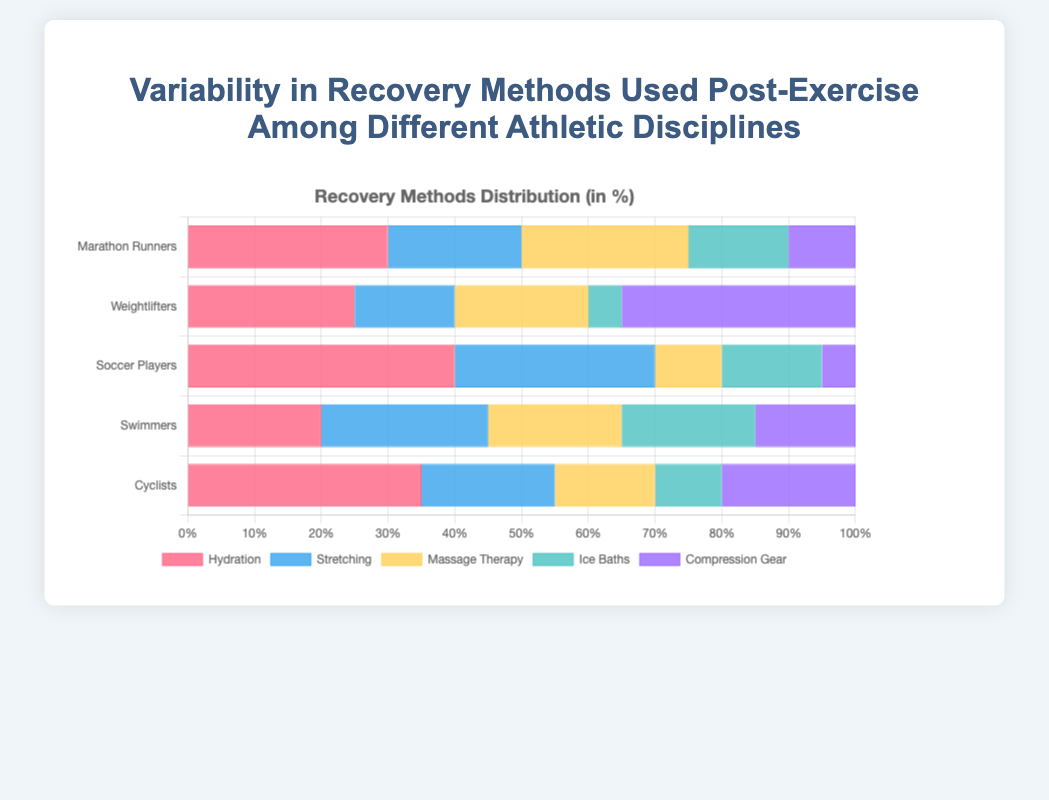Which athletic discipline uses "Hydration" the most? The bar representing "Hydration" for each athletic discipline needs to be checked. Soccer Players have the longest bar for "Hydration".
Answer: Soccer Players What is the total percentage use of "Massage Therapy" by Marathon Runners and Weightlifters? Marathon Runners use "Massage Therapy" 25% and Weightlifters use it 20%. Adding them gives 25 + 20 = 45.
Answer: 45% Which recovery method is least used by Weightlifters? The shortest bar for Weightlifters should be identified. "Ice Baths" have the shortest bar.
Answer: Ice Baths Compare the total use of "Compression Gear" between Weightlifters and Cyclists. Which group uses it more? Weightlifters' "Compression Gear" usage is 35%, and Cyclists' is 20%. 35% is greater than 20%.
Answer: Weightlifters How much more do Soccer Players use "Stretching" compared to Swimmers? Soccer Players use "Stretching" 30%, and Swimmers use it 25%. The difference is 30 - 25 = 5.
Answer: 5% Which recovery method shows the least variability in its usage across all athletic disciplines? Examine the range of usage (difference between maximum and minimum) for each recovery method. "Ice Baths" show the least variability with percentages of 5, 10, 15, 15, and 20.
Answer: Ice Baths Determine the average use of "Ice Baths" across all athletic disciplines. The percentages for "Ice Baths" are 15, 5, 15, 20, and 10. Summing them gives 65. Dividing by 5 (number of disciplines) gives 65/5 = 13.
Answer: 13% If the use of "Stretching" by Cyclists increased by 5%, what would be the new total percentage for "Stretching" across all athletic disciplines? Cyclists currently use "Stretching" 20%. Increasing it by 5% gives 20 + 5 = 25%. The current total for "Stretching" is 110%. Adding the increase gives 110 + 5 = 115%.
Answer: 115% Which athletic discipline has the most balanced use of recovery methods (i.e., least disparity between highest and lowest usage methods)? Examine the disparity (difference between highest and lowest percentage) for each discipline. Swimmers have values from 15% to 25%, yielding a difference of 10%, the smallest among the groups.
Answer: Swimmers 